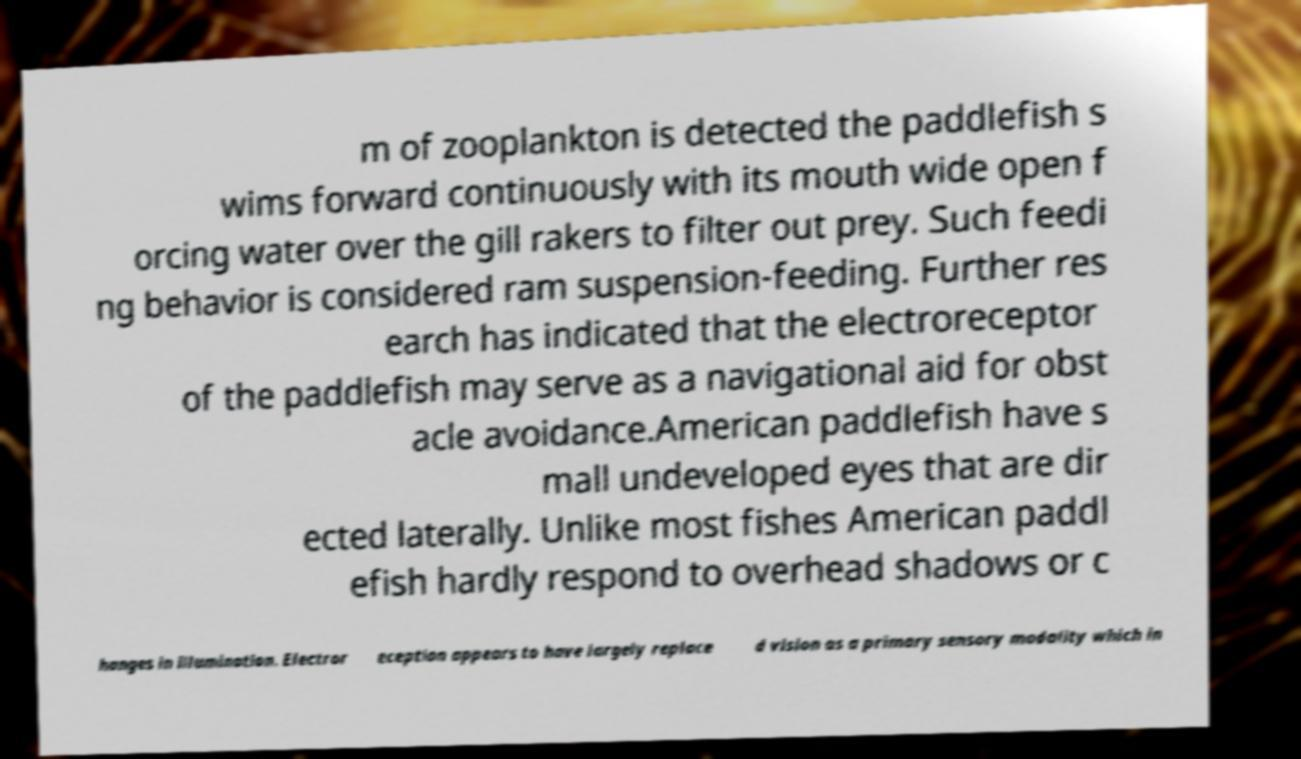I need the written content from this picture converted into text. Can you do that? m of zooplankton is detected the paddlefish s wims forward continuously with its mouth wide open f orcing water over the gill rakers to filter out prey. Such feedi ng behavior is considered ram suspension-feeding. Further res earch has indicated that the electroreceptor of the paddlefish may serve as a navigational aid for obst acle avoidance.American paddlefish have s mall undeveloped eyes that are dir ected laterally. Unlike most fishes American paddl efish hardly respond to overhead shadows or c hanges in illumination. Electror eception appears to have largely replace d vision as a primary sensory modality which in 